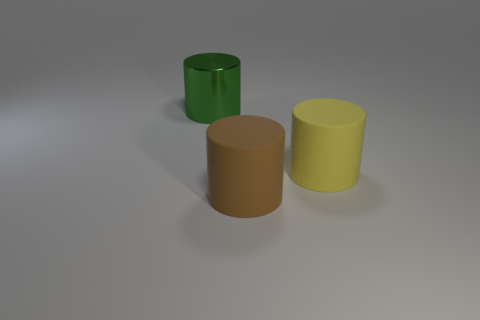Add 3 tiny yellow metallic balls. How many objects exist? 6 Subtract all large red objects. Subtract all metal cylinders. How many objects are left? 2 Add 2 yellow matte cylinders. How many yellow matte cylinders are left? 3 Add 1 yellow cylinders. How many yellow cylinders exist? 2 Subtract 0 red spheres. How many objects are left? 3 